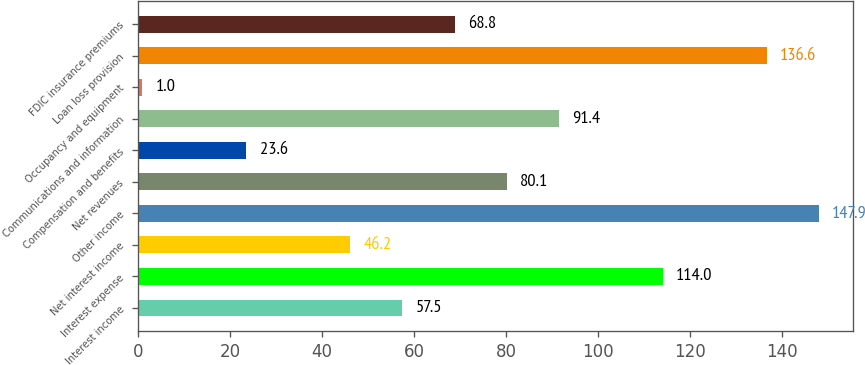Convert chart. <chart><loc_0><loc_0><loc_500><loc_500><bar_chart><fcel>Interest income<fcel>Interest expense<fcel>Net interest income<fcel>Other income<fcel>Net revenues<fcel>Compensation and benefits<fcel>Communications and information<fcel>Occupancy and equipment<fcel>Loan loss provision<fcel>FDIC insurance premiums<nl><fcel>57.5<fcel>114<fcel>46.2<fcel>147.9<fcel>80.1<fcel>23.6<fcel>91.4<fcel>1<fcel>136.6<fcel>68.8<nl></chart> 